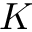Convert formula to latex. <formula><loc_0><loc_0><loc_500><loc_500>K</formula> 